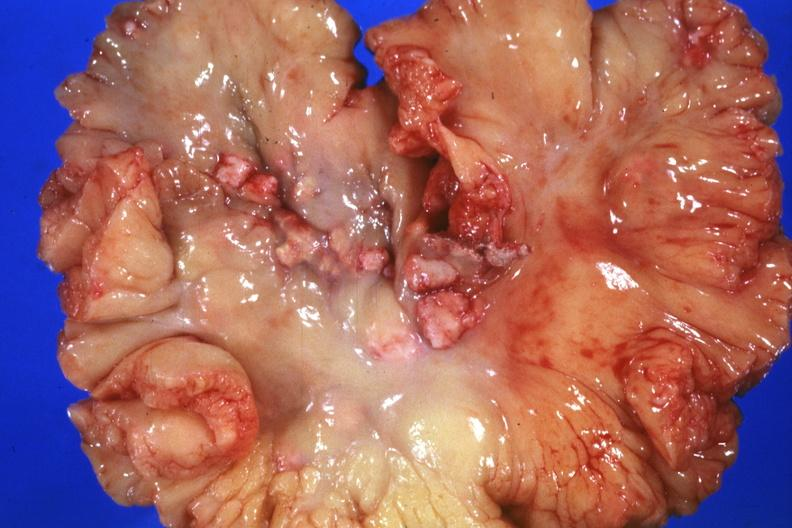s metastatic carcinoma breast present?
Answer the question using a single word or phrase. Yes 